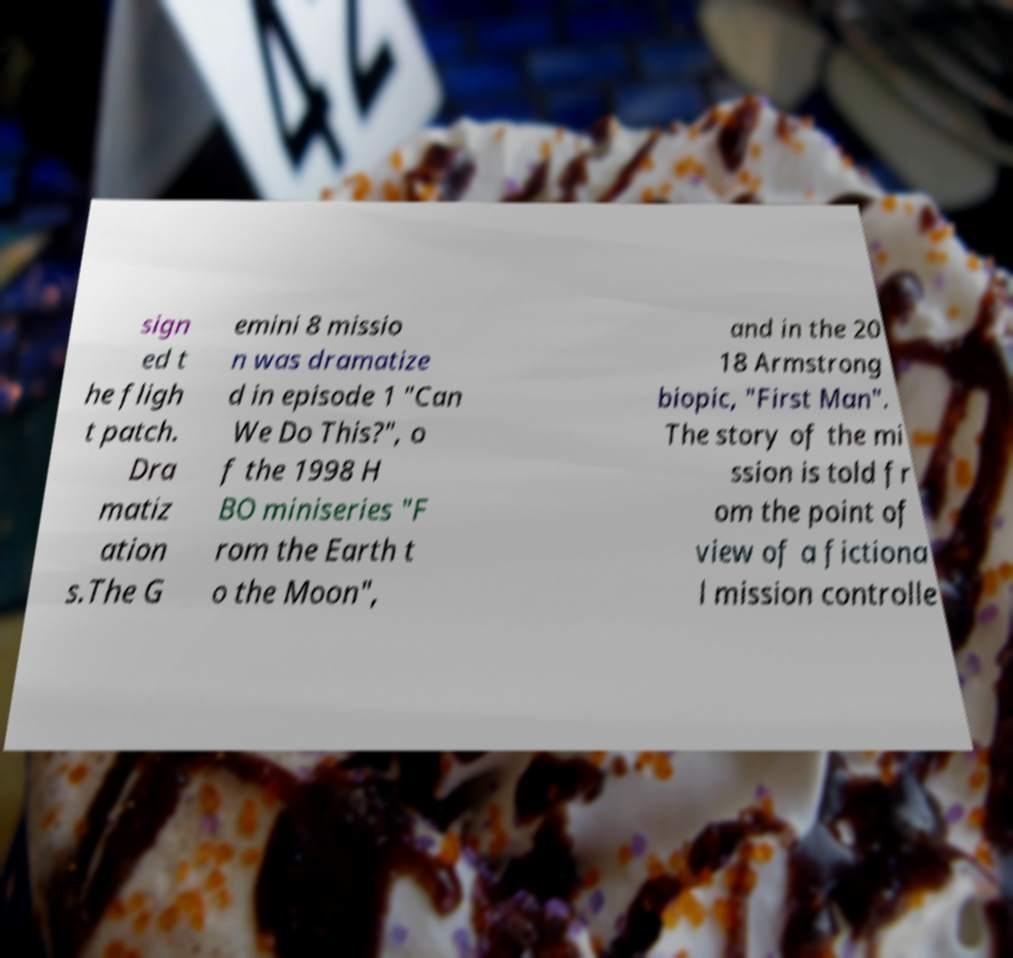Can you accurately transcribe the text from the provided image for me? sign ed t he fligh t patch. Dra matiz ation s.The G emini 8 missio n was dramatize d in episode 1 "Can We Do This?", o f the 1998 H BO miniseries "F rom the Earth t o the Moon", and in the 20 18 Armstrong biopic, "First Man". The story of the mi ssion is told fr om the point of view of a fictiona l mission controlle 